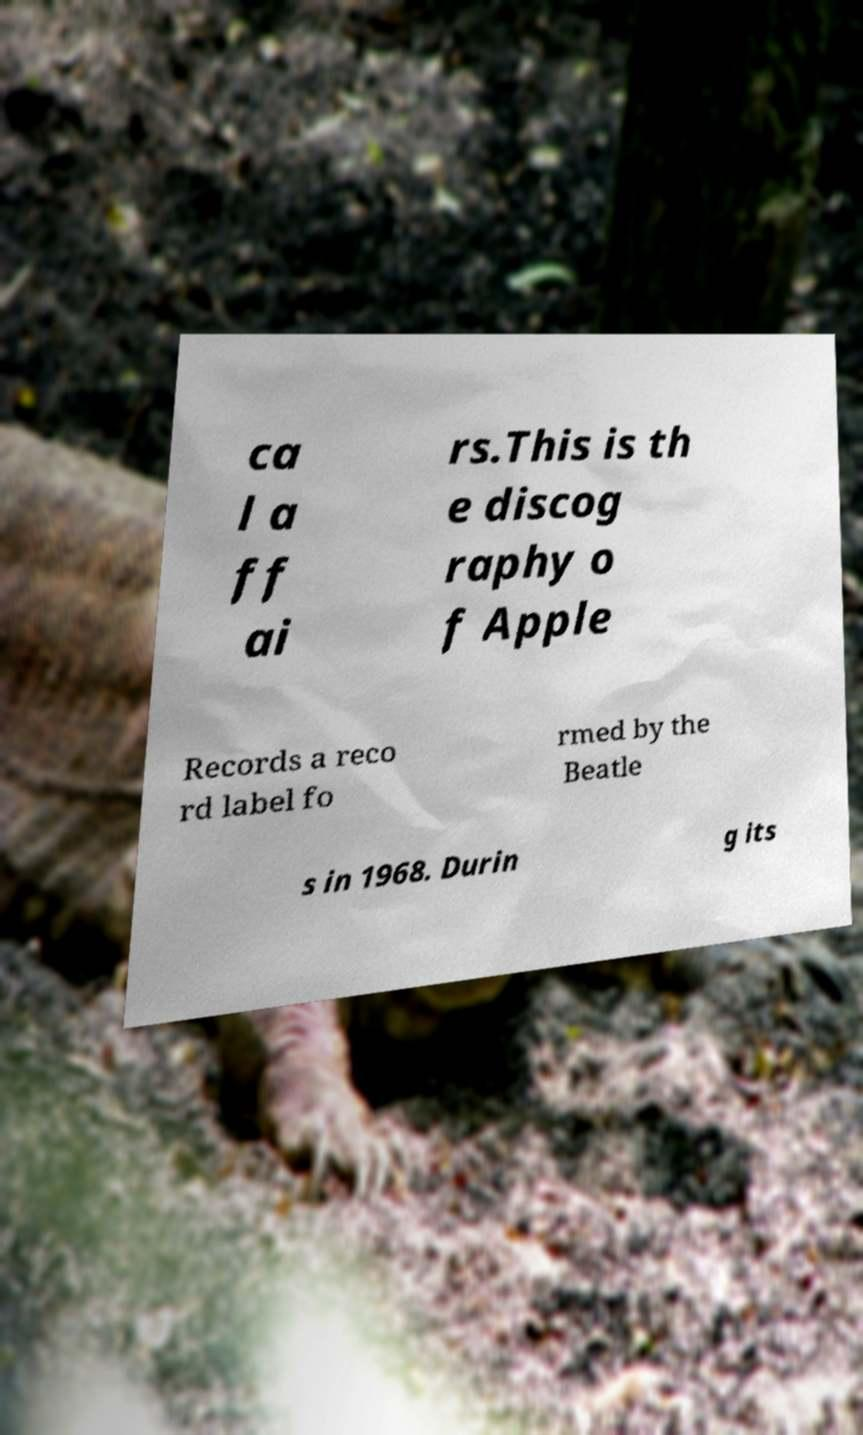Could you extract and type out the text from this image? ca l a ff ai rs.This is th e discog raphy o f Apple Records a reco rd label fo rmed by the Beatle s in 1968. Durin g its 